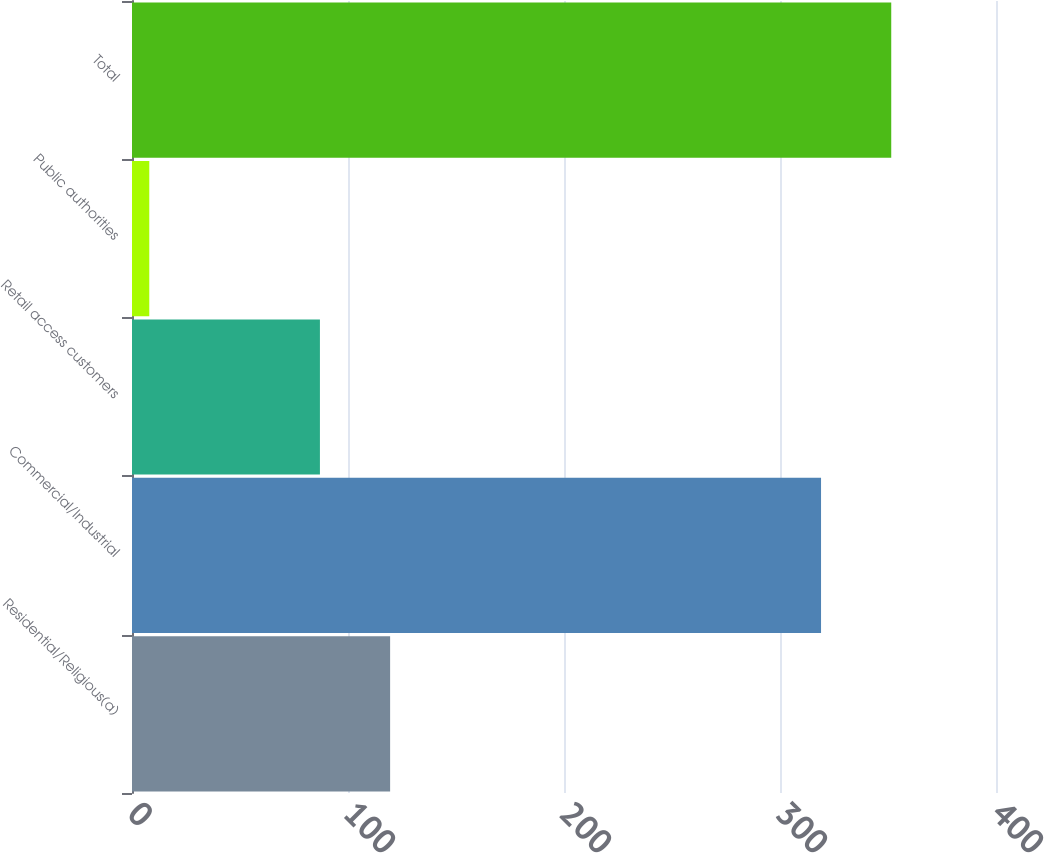Convert chart to OTSL. <chart><loc_0><loc_0><loc_500><loc_500><bar_chart><fcel>Residential/Religious(a)<fcel>Commercial/Industrial<fcel>Retail access customers<fcel>Public authorities<fcel>Total<nl><fcel>119.5<fcel>319<fcel>87<fcel>8<fcel>351.5<nl></chart> 